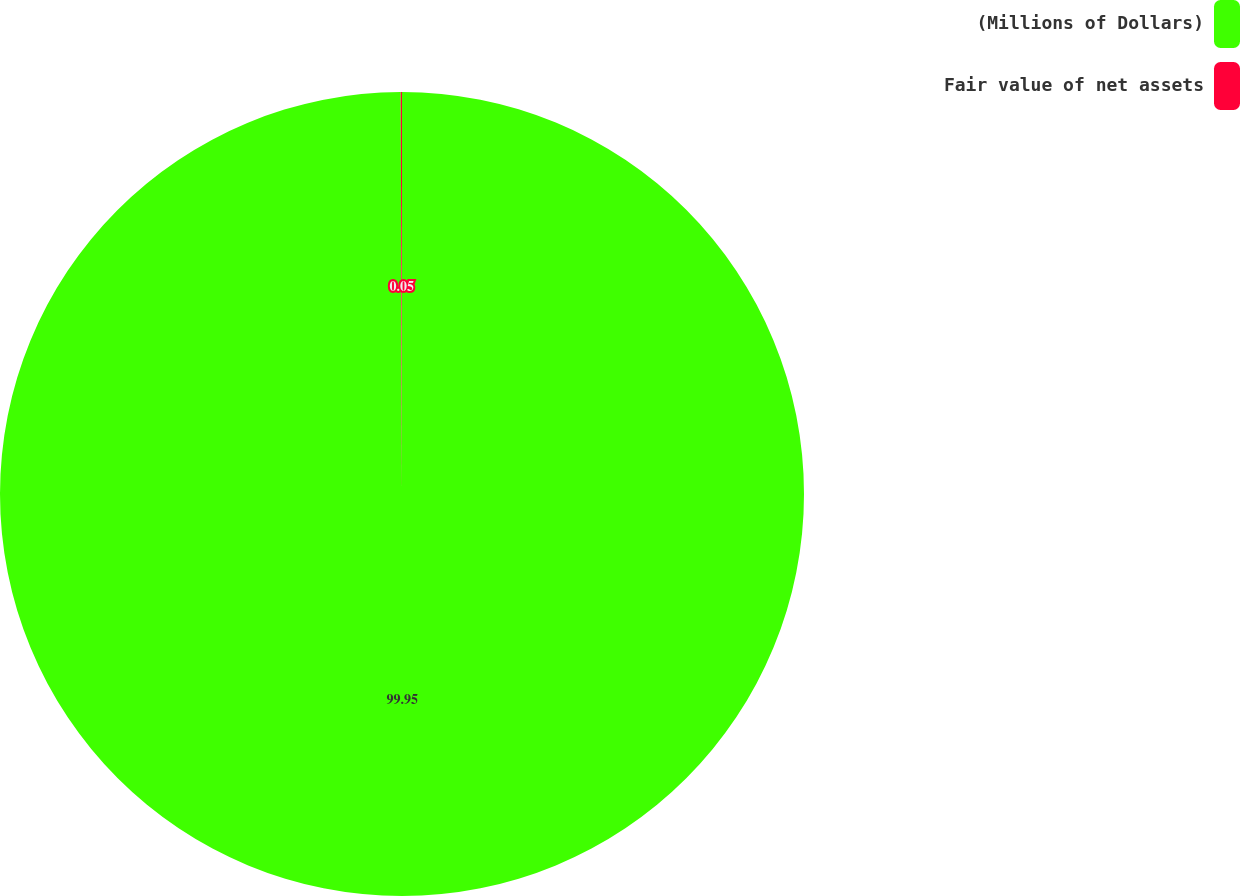<chart> <loc_0><loc_0><loc_500><loc_500><pie_chart><fcel>(Millions of Dollars)<fcel>Fair value of net assets<nl><fcel>99.95%<fcel>0.05%<nl></chart> 